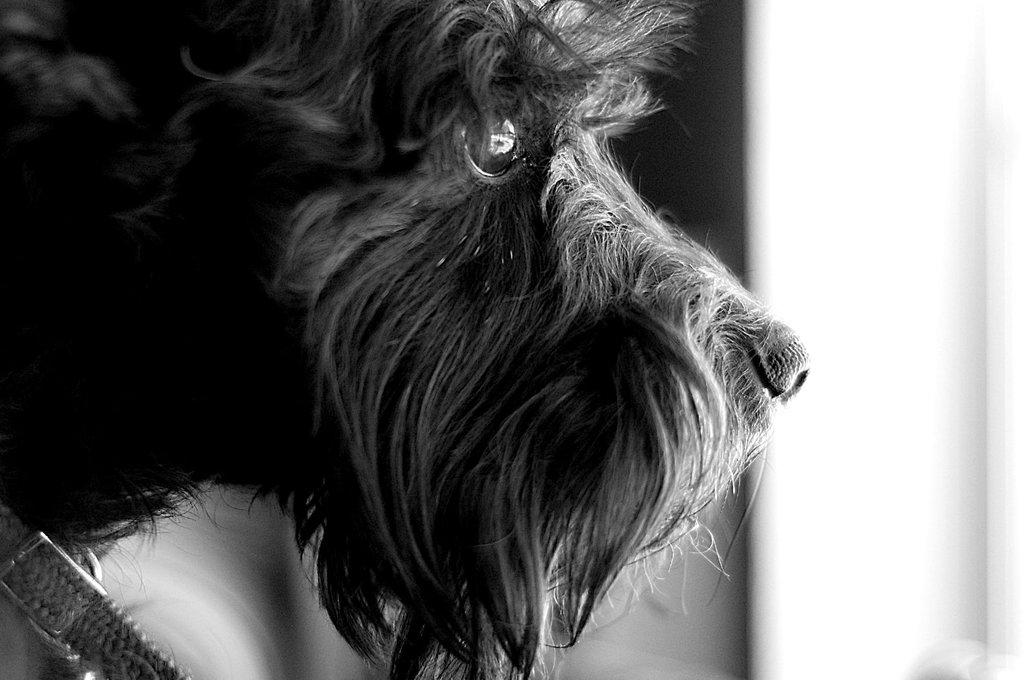What type of animal is in the image? There is a dog in the image. Can you describe the background of the image? The background of the image is blurred. What letters are visible on the dog's collar in the image? There is no information about a collar or letters on the dog's collar in the provided facts. 